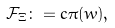<formula> <loc_0><loc_0><loc_500><loc_500>\mathcal { F } _ { \Xi } \colon = c \pi ( w ) ,</formula> 